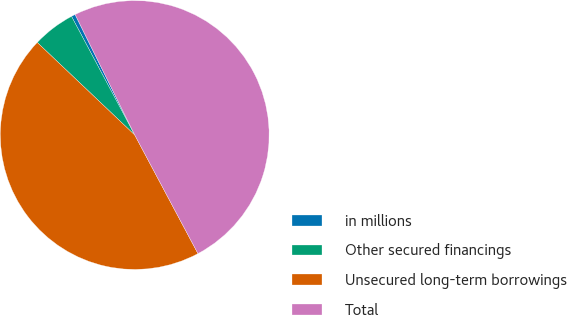Convert chart to OTSL. <chart><loc_0><loc_0><loc_500><loc_500><pie_chart><fcel>in millions<fcel>Other secured financings<fcel>Unsecured long-term borrowings<fcel>Total<nl><fcel>0.48%<fcel>5.12%<fcel>44.88%<fcel>49.52%<nl></chart> 